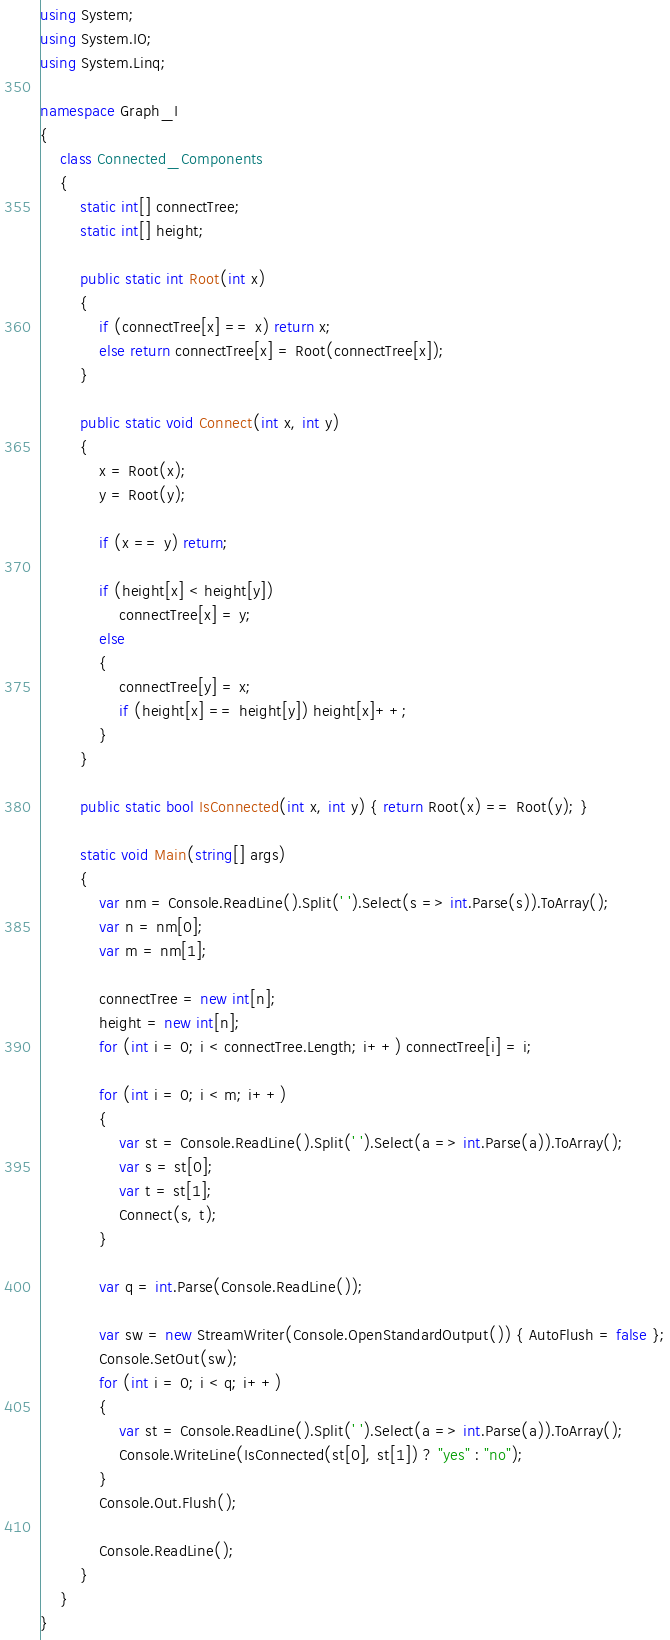Convert code to text. <code><loc_0><loc_0><loc_500><loc_500><_C#_>using System;
using System.IO;
using System.Linq;

namespace Graph_I
{
    class Connected_Components
    {
        static int[] connectTree;
        static int[] height;

        public static int Root(int x)
        {
            if (connectTree[x] == x) return x;
            else return connectTree[x] = Root(connectTree[x]);
        }

        public static void Connect(int x, int y)
        {
            x = Root(x);
            y = Root(y);

            if (x == y) return;

            if (height[x] < height[y])
                connectTree[x] = y;
            else
            {
                connectTree[y] = x;
                if (height[x] == height[y]) height[x]++;
            }
        }

        public static bool IsConnected(int x, int y) { return Root(x) == Root(y); }

        static void Main(string[] args)
        {
            var nm = Console.ReadLine().Split(' ').Select(s => int.Parse(s)).ToArray();
            var n = nm[0];
            var m = nm[1];

            connectTree = new int[n];
            height = new int[n];
            for (int i = 0; i < connectTree.Length; i++) connectTree[i] = i;

            for (int i = 0; i < m; i++)
            {
                var st = Console.ReadLine().Split(' ').Select(a => int.Parse(a)).ToArray();
                var s = st[0];
                var t = st[1];
                Connect(s, t);
            }

            var q = int.Parse(Console.ReadLine());

            var sw = new StreamWriter(Console.OpenStandardOutput()) { AutoFlush = false };
            Console.SetOut(sw);
            for (int i = 0; i < q; i++)
            {
                var st = Console.ReadLine().Split(' ').Select(a => int.Parse(a)).ToArray();
                Console.WriteLine(IsConnected(st[0], st[1]) ? "yes" : "no");
            }
            Console.Out.Flush();

            Console.ReadLine();
        }
    }
}
</code> 